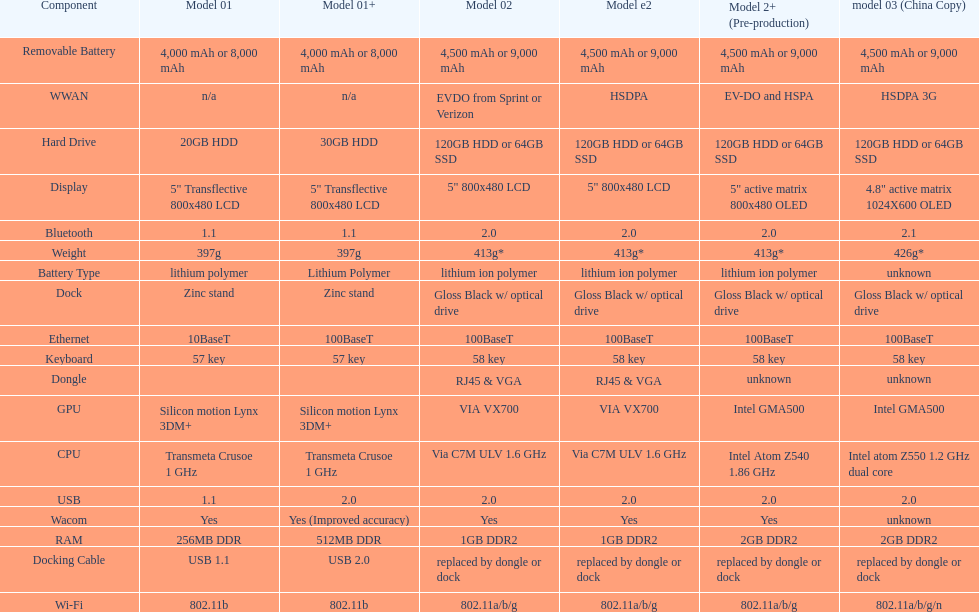Would you be able to parse every entry in this table? {'header': ['Component', 'Model 01', 'Model 01+', 'Model 02', 'Model e2', 'Model 2+ (Pre-production)', 'model 03 (China Copy)'], 'rows': [['Removable Battery', '4,000 mAh or 8,000 mAh', '4,000 mAh or 8,000 mAh', '4,500 mAh or 9,000 mAh', '4,500 mAh or 9,000 mAh', '4,500 mAh or 9,000 mAh', '4,500 mAh or 9,000 mAh'], ['WWAN', 'n/a', 'n/a', 'EVDO from Sprint or Verizon', 'HSDPA', 'EV-DO and HSPA', 'HSDPA 3G'], ['Hard Drive', '20GB HDD', '30GB HDD', '120GB HDD or 64GB SSD', '120GB HDD or 64GB SSD', '120GB HDD or 64GB SSD', '120GB HDD or 64GB SSD'], ['Display', '5" Transflective 800x480 LCD', '5" Transflective 800x480 LCD', '5" 800x480 LCD', '5" 800x480 LCD', '5" active matrix 800x480 OLED', '4.8" active matrix 1024X600 OLED'], ['Bluetooth', '1.1', '1.1', '2.0', '2.0', '2.0', '2.1'], ['Weight', '397g', '397g', '413g*', '413g*', '413g*', '426g*'], ['Battery Type', 'lithium polymer', 'Lithium Polymer', 'lithium ion polymer', 'lithium ion polymer', 'lithium ion polymer', 'unknown'], ['Dock', 'Zinc stand', 'Zinc stand', 'Gloss Black w/ optical drive', 'Gloss Black w/ optical drive', 'Gloss Black w/ optical drive', 'Gloss Black w/ optical drive'], ['Ethernet', '10BaseT', '100BaseT', '100BaseT', '100BaseT', '100BaseT', '100BaseT'], ['Keyboard', '57 key', '57 key', '58 key', '58 key', '58 key', '58 key'], ['Dongle', '', '', 'RJ45 & VGA', 'RJ45 & VGA', 'unknown', 'unknown'], ['GPU', 'Silicon motion Lynx 3DM+', 'Silicon motion Lynx 3DM+', 'VIA VX700', 'VIA VX700', 'Intel GMA500', 'Intel GMA500'], ['CPU', 'Transmeta Crusoe 1\xa0GHz', 'Transmeta Crusoe 1\xa0GHz', 'Via C7M ULV 1.6\xa0GHz', 'Via C7M ULV 1.6\xa0GHz', 'Intel Atom Z540 1.86\xa0GHz', 'Intel atom Z550 1.2\xa0GHz dual core'], ['USB', '1.1', '2.0', '2.0', '2.0', '2.0', '2.0'], ['Wacom', 'Yes', 'Yes (Improved accuracy)', 'Yes', 'Yes', 'Yes', 'unknown'], ['RAM', '256MB DDR', '512MB DDR', '1GB DDR2', '1GB DDR2', '2GB DDR2', '2GB DDR2'], ['Docking Cable', 'USB 1.1', 'USB 2.0', 'replaced by dongle or dock', 'replaced by dongle or dock', 'replaced by dongle or dock', 'replaced by dongle or dock'], ['Wi-Fi', '802.11b', '802.11b', '802.11a/b/g', '802.11a/b/g', '802.11a/b/g', '802.11a/b/g/n']]} How many models have 1.6ghz? 2. 